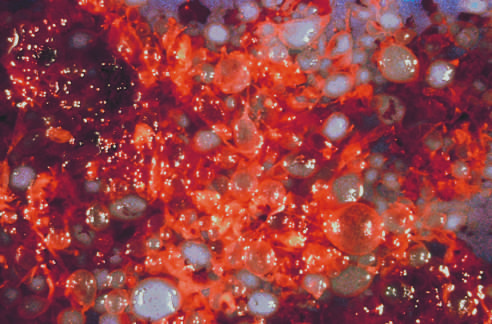what does the complete hydatidiform mole consist of?
Answer the question using a single word or phrase. Numerous swollen villi 